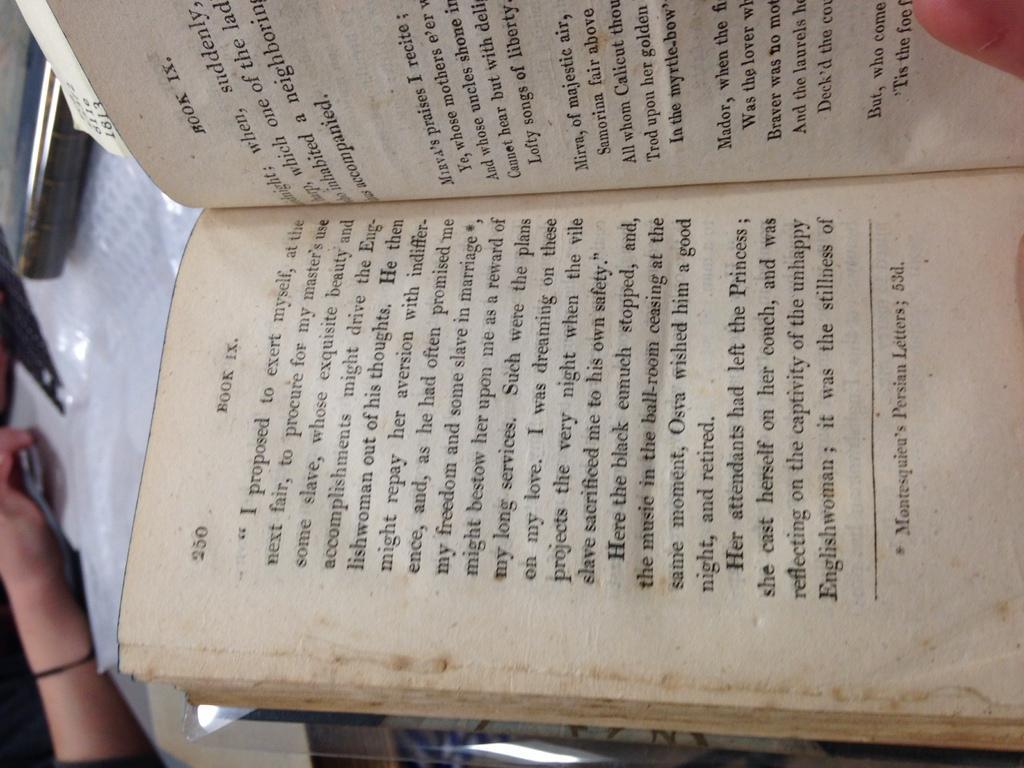Could you give a brief overview of what you see in this image? In the picture i can see pages of a book in which there are some words written. 